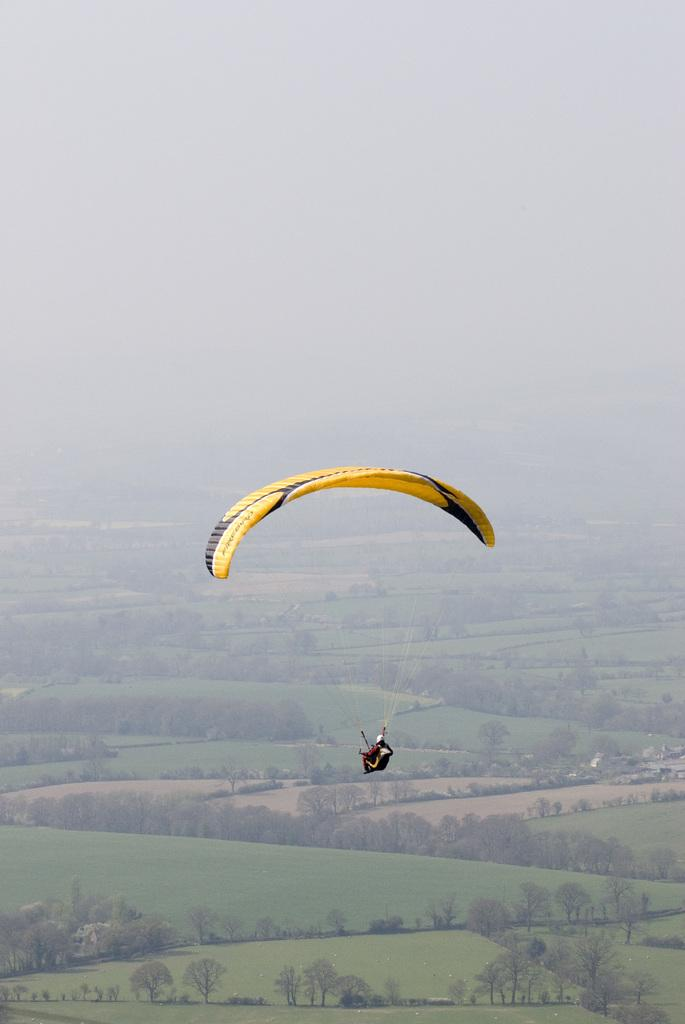What activity is the person in the image engaged in? The person is paragliding in the air. What type of natural environment can be seen in the background of the image? There are trees, fields, and houses in the background of the image. What part of the natural environment is visible in the image? The sky is visible in the background of the image. What type of rail can be seen supporting the paraglider in the image? There is no rail present in the image; the person is paragliding in the air without any visible support. Can you see any dinosaurs in the image? No, there are no dinosaurs present in the image. Is there any sleet visible in the image? No, there is no sleet visible in the image. 